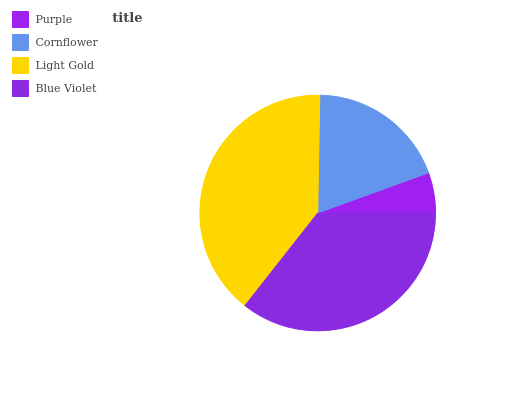Is Purple the minimum?
Answer yes or no. Yes. Is Light Gold the maximum?
Answer yes or no. Yes. Is Cornflower the minimum?
Answer yes or no. No. Is Cornflower the maximum?
Answer yes or no. No. Is Cornflower greater than Purple?
Answer yes or no. Yes. Is Purple less than Cornflower?
Answer yes or no. Yes. Is Purple greater than Cornflower?
Answer yes or no. No. Is Cornflower less than Purple?
Answer yes or no. No. Is Blue Violet the high median?
Answer yes or no. Yes. Is Cornflower the low median?
Answer yes or no. Yes. Is Light Gold the high median?
Answer yes or no. No. Is Light Gold the low median?
Answer yes or no. No. 